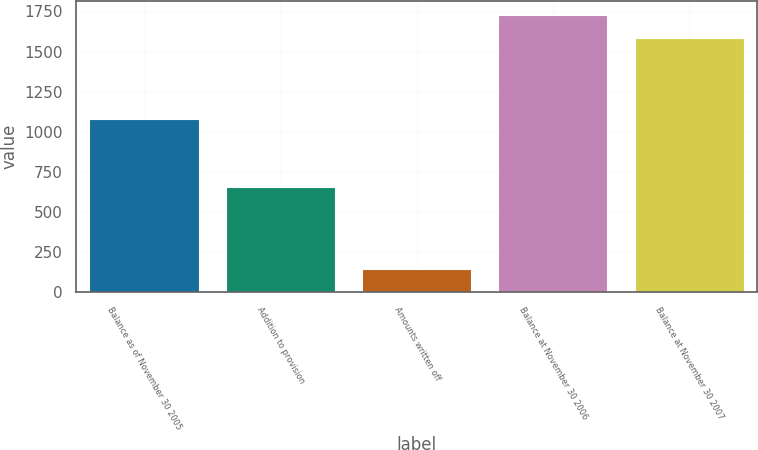<chart> <loc_0><loc_0><loc_500><loc_500><bar_chart><fcel>Balance as of November 30 2005<fcel>Addition to provision<fcel>Amounts written off<fcel>Balance at November 30 2006<fcel>Balance at November 30 2007<nl><fcel>1078<fcel>654<fcel>144<fcel>1728.4<fcel>1584<nl></chart> 